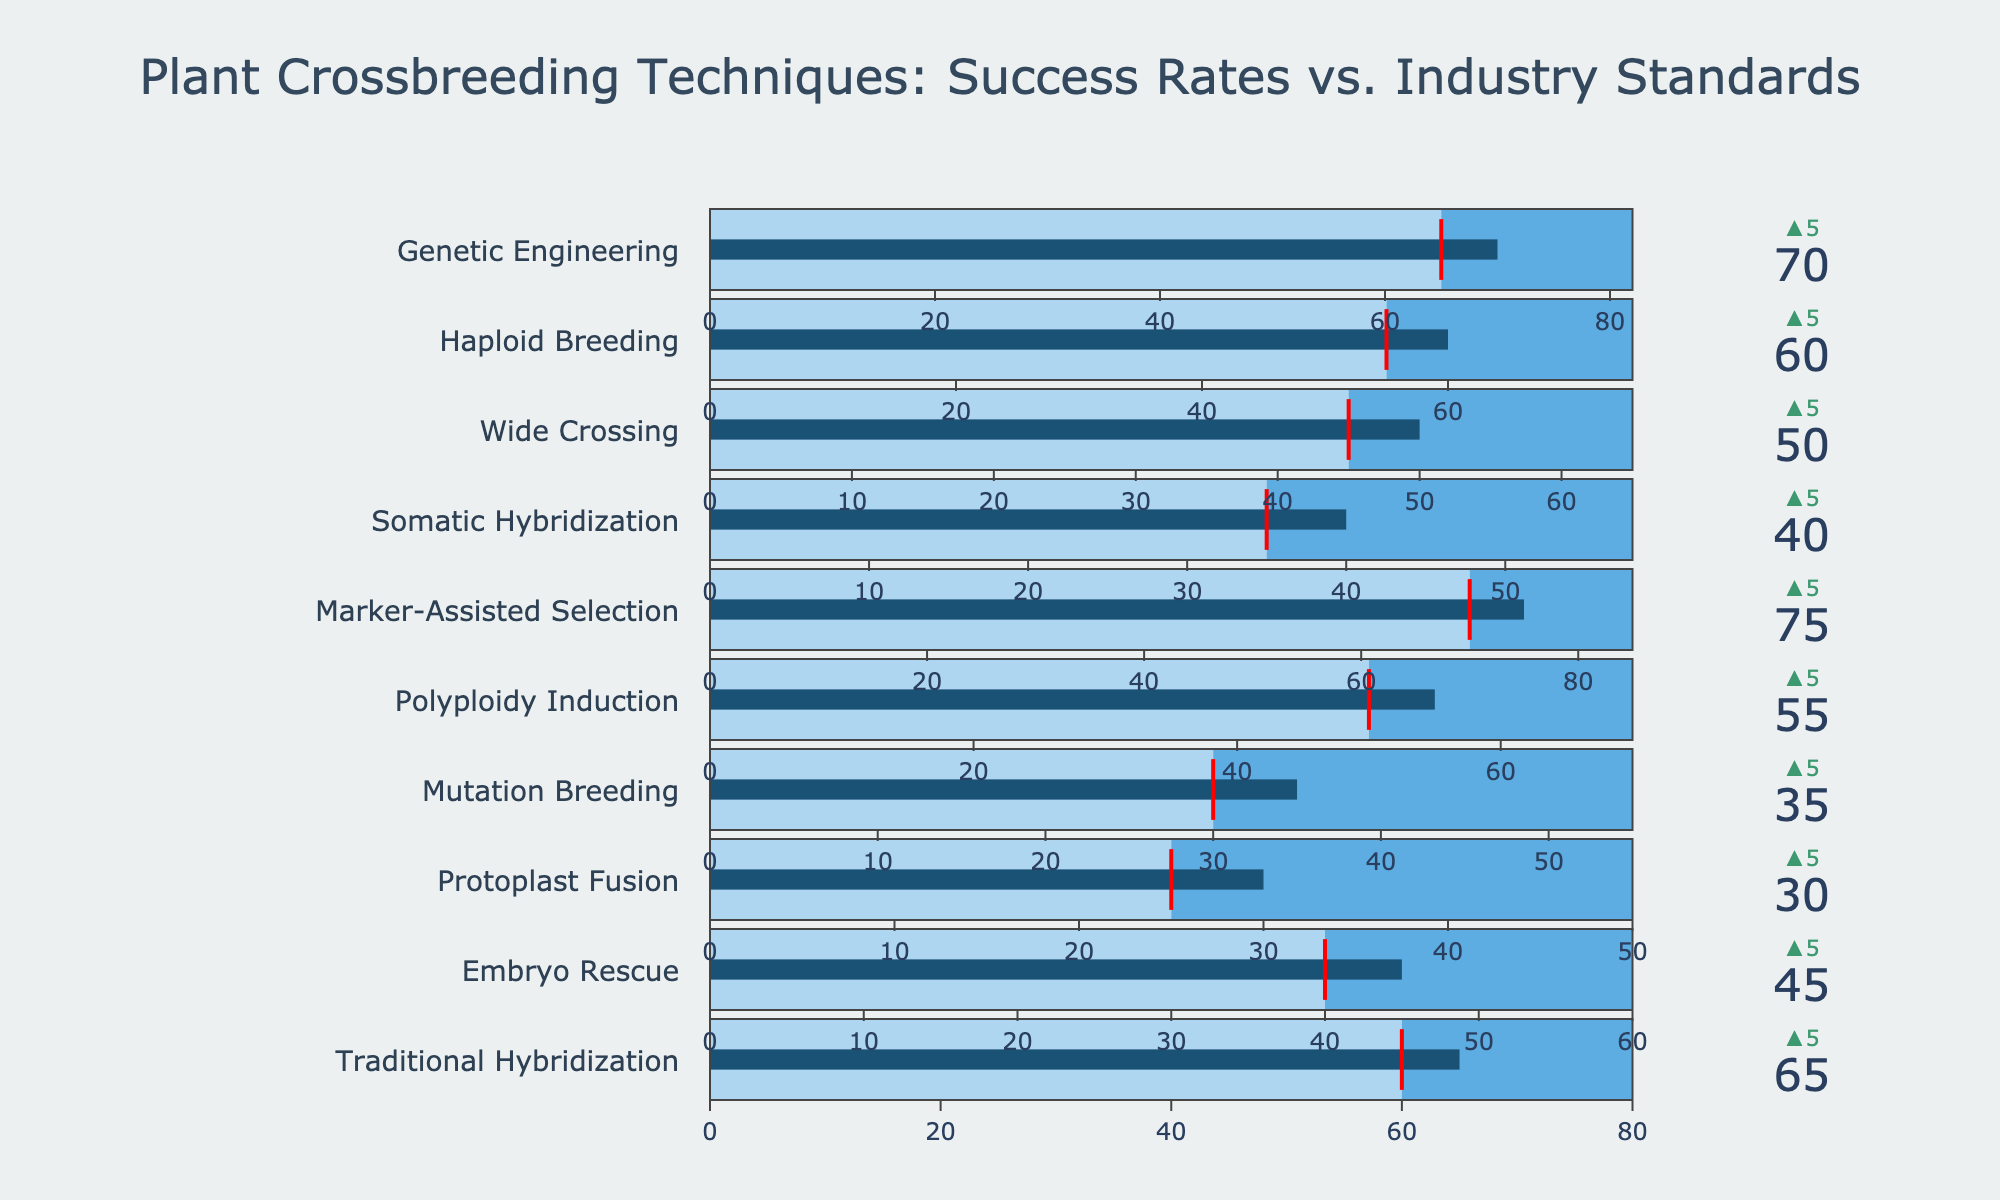What's the highest actual success rate among the different techniques? To find the highest actual success rate, we look at the values provided for each technique. Marker-Assisted Selection has the highest actual success rate of 75, visible on the top of its bullet chart.
Answer: 75 Which technique has the largest positive difference between its actual success rate and the industry standard? By comparing the 'Actual Success Rate' and 'Industry Standard' for each technique, the largest difference is seen in Marker-Assisted Selection, which has a difference of 75 - 70 = 5.
Answer: Marker-Assisted Selection What is the average industry standard success rate for all techniques? To calculate the average, sum all the industry standard values and divide by the number of techniques. (60 + 40 + 25 + 30 + 50 + 70 + 35 + 45 + 55 + 65) / 10 = 475 / 10
Answer: 47.5 Which technique has the closest actual success rate to its maximum observed rate? By comparing the 'Actual Success Rate' and 'Maximum Observed' rate for each technique, Traditional Hybridization has the closest, with 65 to 80, a difference of 15.
Answer: Traditional Hybridization What is the difference between the highest and lowest actual success rates among the techniques? Identify the highest and lowest values among the actual success rates (75 for Marker-Assisted Selection and 30 for Protoplast Fusion), then subtract the lowest from the highest: 75 - 30 = 45.
Answer: 45 Does any technique have an actual success rate below the industry standard? Each technique's 'Actual Success Rate' should be examined against its 'Industry Standard'. In this set, all actual success rates are above or equal to their corresponding industry standards.
Answer: No Which technique has the widest range up to its maximum observed rate? Calculate the difference between the 'Maximum Observed' rate and the 'Actual Success Rate' for each technique. Protoplast Fusion has the widest range with 50 - 30 = 20.
Answer: Protoplast Fusion What is the median of the actual success rates? List the actual success rates in ascending order: [30, 35, 40, 45, 50, 55, 60, 65, 70, 75]. The median is the middle value, which is the average of the 5th and 6th values, (50+55) / 2 = 52.5.
Answer: 52.5 